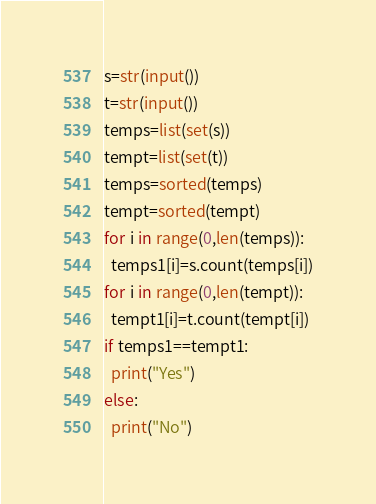Convert code to text. <code><loc_0><loc_0><loc_500><loc_500><_Python_>s=str(input())
t=str(input())
temps=list(set(s))
tempt=list(set(t))
temps=sorted(temps)
tempt=sorted(tempt)
for i in range(0,len(temps)):
  temps1[i]=s.count(temps[i])
for i in range(0,len(tempt)):
  tempt1[i]=t.count(tempt[i])
if temps1==tempt1:
  print("Yes")
else:
  print("No")</code> 